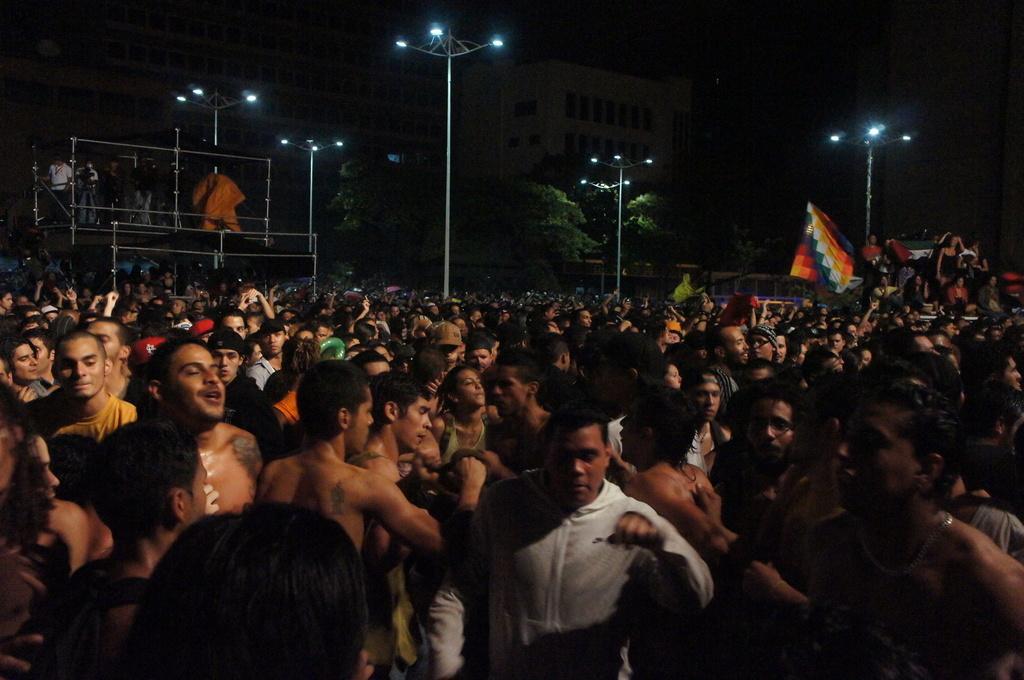Please provide a concise description of this image. Many people are standing. There are poles, lights, flag, trees and buildings at the back. 